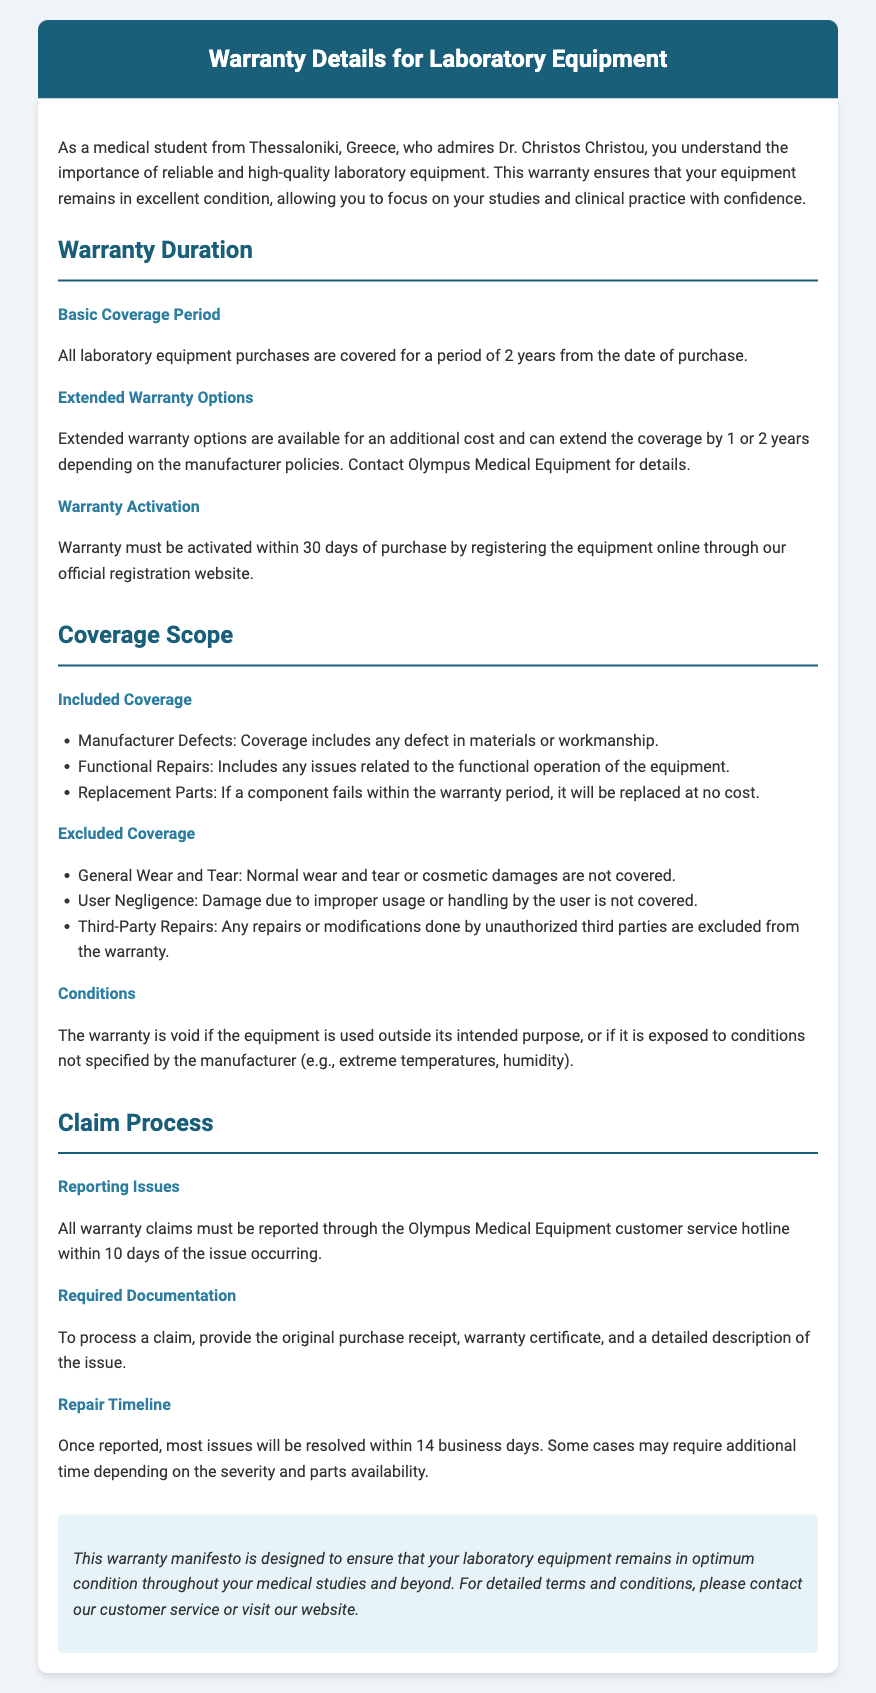What is the basic coverage period? The basic coverage period for all laboratory equipment purchases is stated in the document.
Answer: 2 years What must be provided to process a warranty claim? The document specifies the required documentation needed for warranty claims.
Answer: Original purchase receipt, warranty certificate, and a detailed description of the issue What are warranty claims required to be reported through? The document outlines how warranty claims should be reported, referring to a specific contact method.
Answer: Customer service hotline How long can extended warranty options increase the coverage? The document mentions the duration that extended warranty options can add to the basic coverage.
Answer: 1 or 2 years What conditions void the warranty? The document lists conditions under which the warranty becomes void.
Answer: Usage outside intended purpose What is excluded from warranty coverage? The document explicitly states what is not included in the warranty coverage.
Answer: General wear and tear What is the repair timeline after reporting an issue? The document provides information on how quickly issues are typically resolved when reported.
Answer: 14 business days How long do you have to activate the warranty after purchase? The document mentions the time frame in which warranty activation must occur.
Answer: 30 days What kind of defects does the warranty cover? The included coverage section describes the types of defects that are protected under the warranty.
Answer: Manufacturer defects 